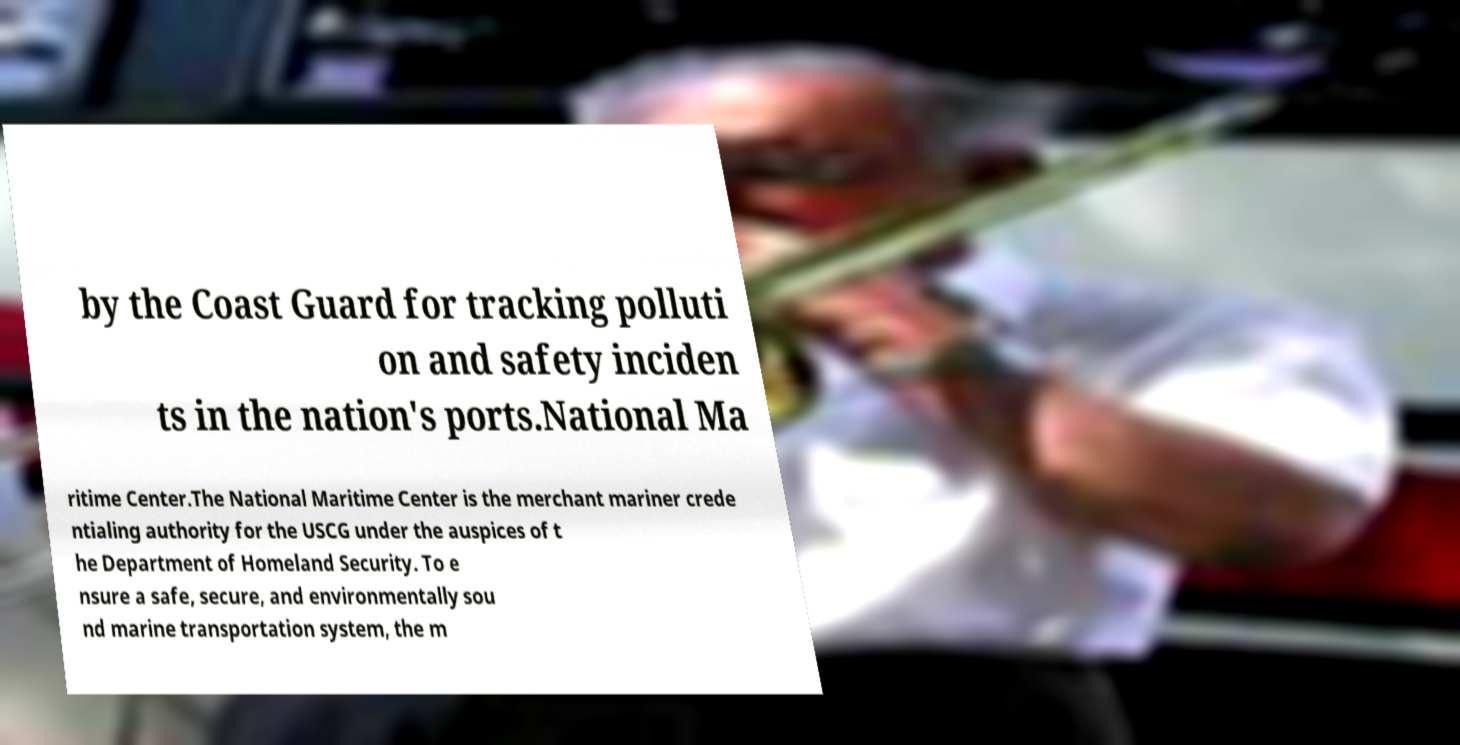Please identify and transcribe the text found in this image. by the Coast Guard for tracking polluti on and safety inciden ts in the nation's ports.National Ma ritime Center.The National Maritime Center is the merchant mariner crede ntialing authority for the USCG under the auspices of t he Department of Homeland Security. To e nsure a safe, secure, and environmentally sou nd marine transportation system, the m 